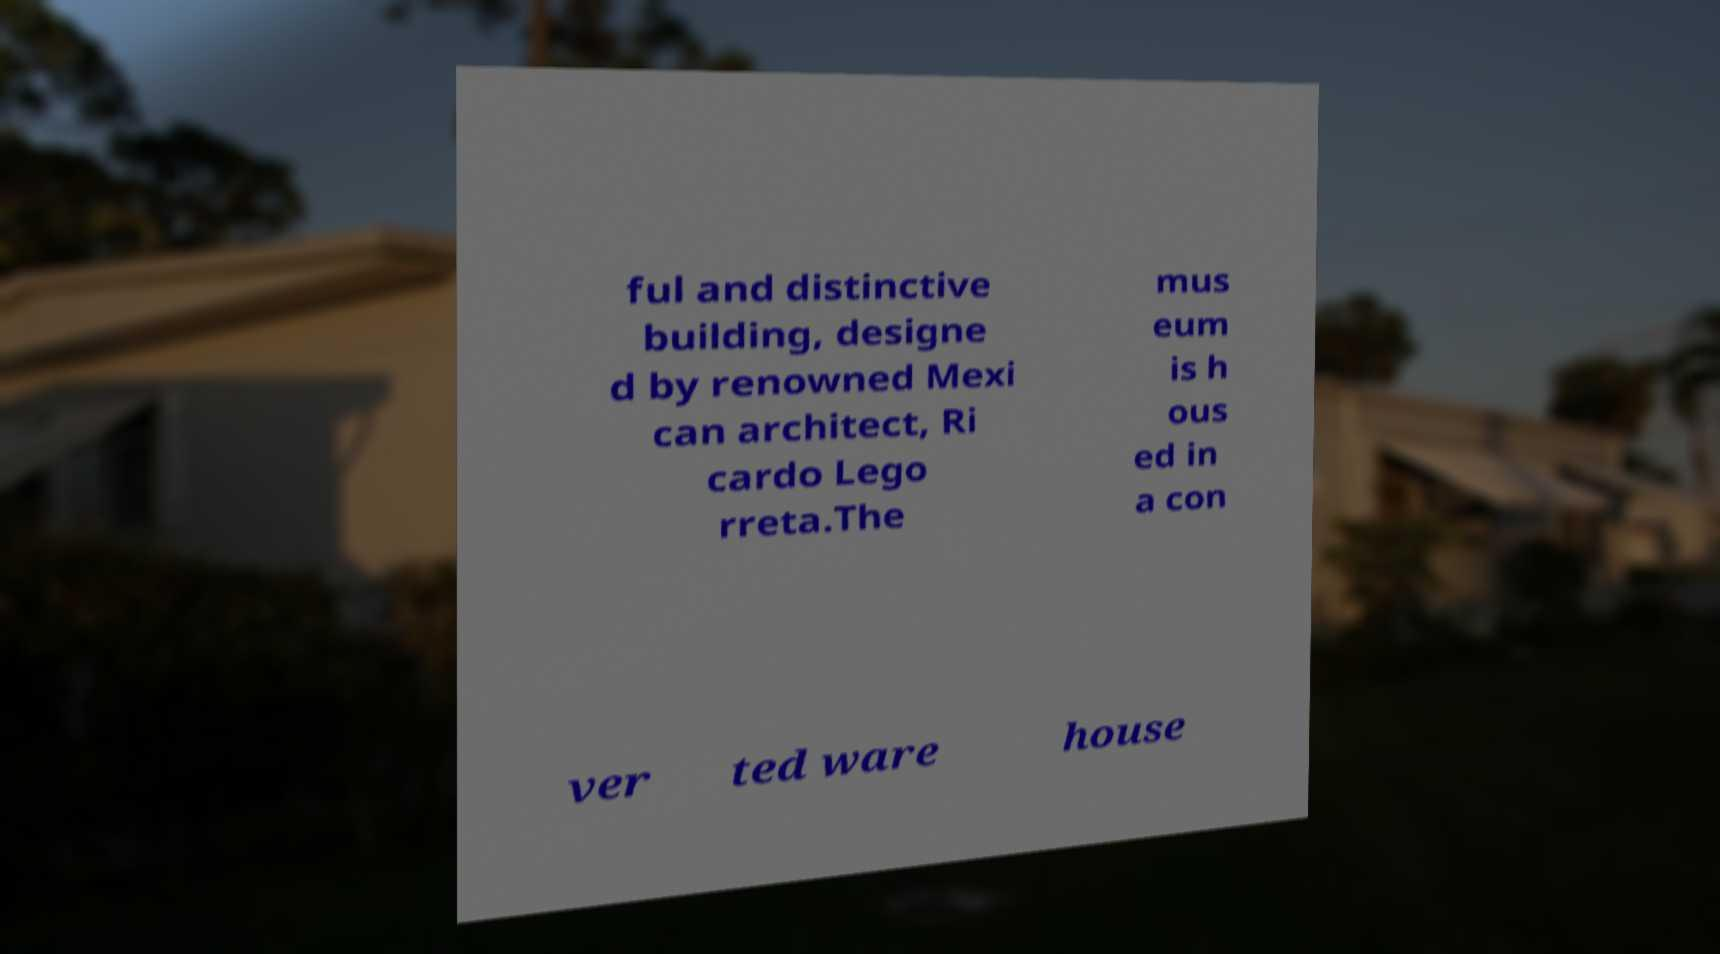Could you assist in decoding the text presented in this image and type it out clearly? ful and distinctive building, designe d by renowned Mexi can architect, Ri cardo Lego rreta.The mus eum is h ous ed in a con ver ted ware house 